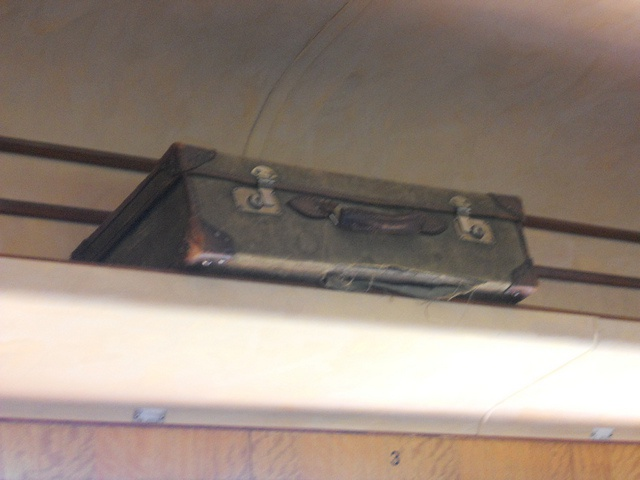Describe the objects in this image and their specific colors. I can see a suitcase in brown, gray, and black tones in this image. 